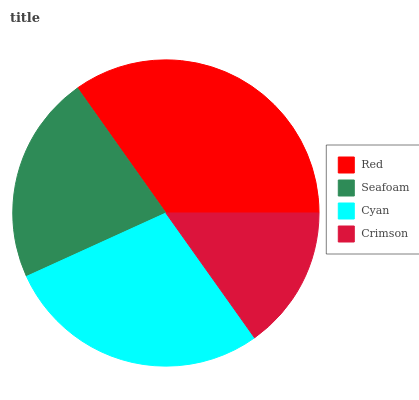Is Crimson the minimum?
Answer yes or no. Yes. Is Red the maximum?
Answer yes or no. Yes. Is Seafoam the minimum?
Answer yes or no. No. Is Seafoam the maximum?
Answer yes or no. No. Is Red greater than Seafoam?
Answer yes or no. Yes. Is Seafoam less than Red?
Answer yes or no. Yes. Is Seafoam greater than Red?
Answer yes or no. No. Is Red less than Seafoam?
Answer yes or no. No. Is Cyan the high median?
Answer yes or no. Yes. Is Seafoam the low median?
Answer yes or no. Yes. Is Crimson the high median?
Answer yes or no. No. Is Crimson the low median?
Answer yes or no. No. 